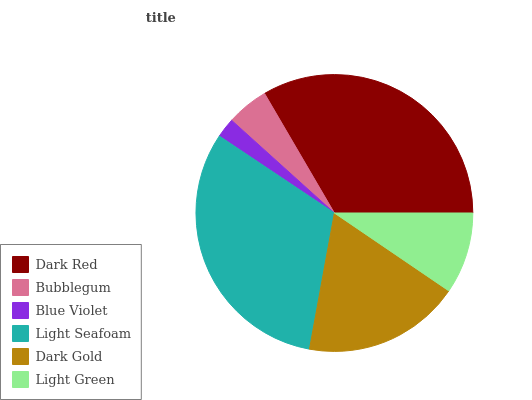Is Blue Violet the minimum?
Answer yes or no. Yes. Is Dark Red the maximum?
Answer yes or no. Yes. Is Bubblegum the minimum?
Answer yes or no. No. Is Bubblegum the maximum?
Answer yes or no. No. Is Dark Red greater than Bubblegum?
Answer yes or no. Yes. Is Bubblegum less than Dark Red?
Answer yes or no. Yes. Is Bubblegum greater than Dark Red?
Answer yes or no. No. Is Dark Red less than Bubblegum?
Answer yes or no. No. Is Dark Gold the high median?
Answer yes or no. Yes. Is Light Green the low median?
Answer yes or no. Yes. Is Light Seafoam the high median?
Answer yes or no. No. Is Light Seafoam the low median?
Answer yes or no. No. 